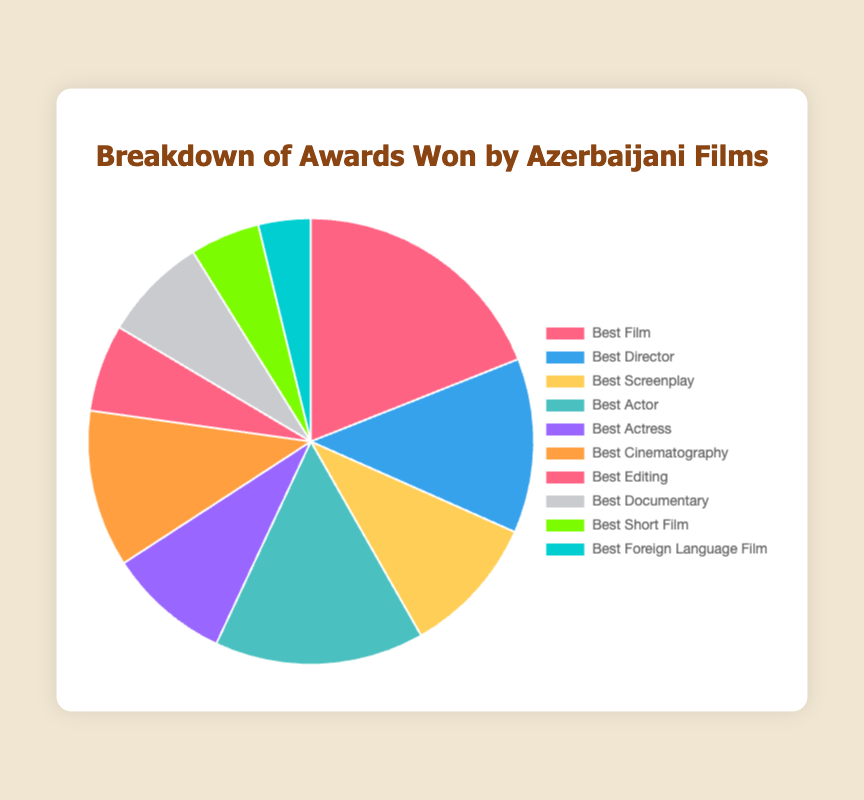Which award category received the highest number of awards? By examining the largest slice in the pie chart, we can see that "Best Film" has the largest share. Therefore, it received the highest number of awards.
Answer: Best Film Which category has fewer awards than Best Actor but more than Best Screenplay? We need to find a category with awards between 12 (Best Actor) and 8 (Best Screenplay). By checking the pie chart, "Best Cinematography" with 9 awards fits this criterion.
Answer: Best Cinematography What are the total awards received by Best Director and Best Screenplay combined? Adding the awards in these two categories: Best Director (10) + Best Screenplay (8) = 18
Answer: 18 Compare the number of awards for Best Actress and Best Documentary. Which has more awards? Looking at the pie chart, Best Actress has 7 awards, whereas Best Documentary has 6 awards. So, Best Actress has more awards.
Answer: Best Actress What is the difference in the number of awards between the categories receiving the most and the least awards? The most awards are received by Best Film (15) and the least by Best Foreign Language Film (3). The difference is 15 - 3 = 12
Answer: 12 Which color represents the Best Cinematography category? By visually identifying the color assigned to the "Best Cinematography" slice, we can see it is represented by a color with a light brown or orange hue.
Answer: Light brown/orange How many more awards does Best Actor have compared to Best Short Film? Best Actor has 12 awards, and Best Short Film has 4. The difference is 12 - 4 = 8
Answer: 8 If we combine the total awards won by Best Editing and Best Documentary, will it be more than the awards for Best Film? Adding Best Editing (5) + Best Documentary (6) gives us 11, which is less than the 15 awards for Best Film, so no.
Answer: No Calculate the average number of awards per category. Sum all the awards: 15 + 10 + 8 + 12 + 7 + 9 + 5 + 6 + 4 + 3 = 79. There are 10 categories, so the average is 79/10 = 7.9
Answer: 7.9 